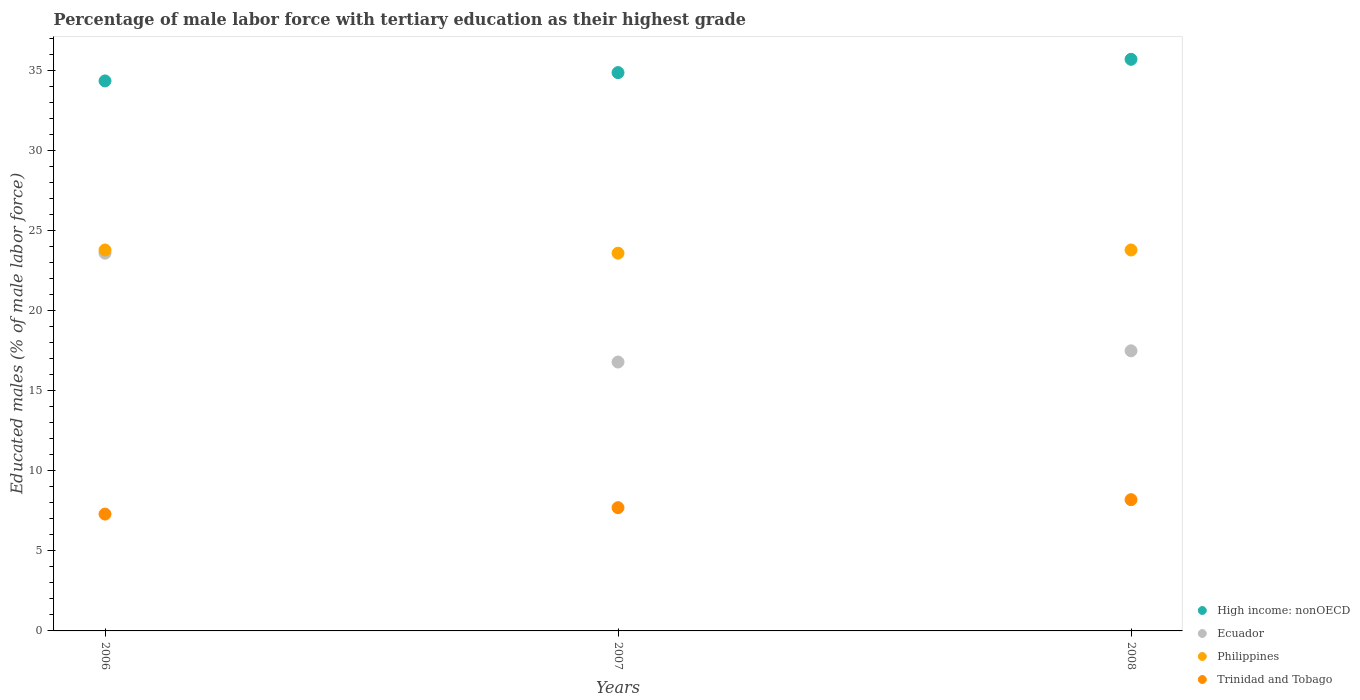Is the number of dotlines equal to the number of legend labels?
Keep it short and to the point. Yes. What is the percentage of male labor force with tertiary education in High income: nonOECD in 2006?
Provide a short and direct response. 34.36. Across all years, what is the maximum percentage of male labor force with tertiary education in Ecuador?
Ensure brevity in your answer.  23.6. Across all years, what is the minimum percentage of male labor force with tertiary education in Philippines?
Give a very brief answer. 23.6. In which year was the percentage of male labor force with tertiary education in Ecuador minimum?
Your response must be concise. 2007. What is the total percentage of male labor force with tertiary education in Philippines in the graph?
Your answer should be very brief. 71.2. What is the difference between the percentage of male labor force with tertiary education in Philippines in 2006 and that in 2007?
Your response must be concise. 0.2. What is the difference between the percentage of male labor force with tertiary education in Ecuador in 2006 and the percentage of male labor force with tertiary education in High income: nonOECD in 2008?
Keep it short and to the point. -12.11. What is the average percentage of male labor force with tertiary education in Trinidad and Tobago per year?
Your answer should be compact. 7.73. In the year 2006, what is the difference between the percentage of male labor force with tertiary education in Trinidad and Tobago and percentage of male labor force with tertiary education in Philippines?
Give a very brief answer. -16.5. In how many years, is the percentage of male labor force with tertiary education in Ecuador greater than 6 %?
Provide a short and direct response. 3. What is the ratio of the percentage of male labor force with tertiary education in Trinidad and Tobago in 2006 to that in 2008?
Your response must be concise. 0.89. Is the percentage of male labor force with tertiary education in Philippines in 2006 less than that in 2008?
Ensure brevity in your answer.  No. Is the difference between the percentage of male labor force with tertiary education in Trinidad and Tobago in 2006 and 2007 greater than the difference between the percentage of male labor force with tertiary education in Philippines in 2006 and 2007?
Your answer should be very brief. No. What is the difference between the highest and the second highest percentage of male labor force with tertiary education in High income: nonOECD?
Give a very brief answer. 0.83. What is the difference between the highest and the lowest percentage of male labor force with tertiary education in Ecuador?
Ensure brevity in your answer.  6.8. In how many years, is the percentage of male labor force with tertiary education in Ecuador greater than the average percentage of male labor force with tertiary education in Ecuador taken over all years?
Keep it short and to the point. 1. Is the sum of the percentage of male labor force with tertiary education in High income: nonOECD in 2006 and 2008 greater than the maximum percentage of male labor force with tertiary education in Philippines across all years?
Your answer should be very brief. Yes. Does the percentage of male labor force with tertiary education in Philippines monotonically increase over the years?
Ensure brevity in your answer.  No. Is the percentage of male labor force with tertiary education in Philippines strictly less than the percentage of male labor force with tertiary education in Ecuador over the years?
Your response must be concise. No. Are the values on the major ticks of Y-axis written in scientific E-notation?
Offer a very short reply. No. Does the graph contain any zero values?
Your answer should be compact. No. Does the graph contain grids?
Your answer should be compact. No. Where does the legend appear in the graph?
Your answer should be compact. Bottom right. How many legend labels are there?
Keep it short and to the point. 4. What is the title of the graph?
Your answer should be compact. Percentage of male labor force with tertiary education as their highest grade. What is the label or title of the X-axis?
Make the answer very short. Years. What is the label or title of the Y-axis?
Provide a short and direct response. Educated males (% of male labor force). What is the Educated males (% of male labor force) in High income: nonOECD in 2006?
Make the answer very short. 34.36. What is the Educated males (% of male labor force) in Ecuador in 2006?
Make the answer very short. 23.6. What is the Educated males (% of male labor force) in Philippines in 2006?
Your answer should be very brief. 23.8. What is the Educated males (% of male labor force) in Trinidad and Tobago in 2006?
Ensure brevity in your answer.  7.3. What is the Educated males (% of male labor force) in High income: nonOECD in 2007?
Your response must be concise. 34.88. What is the Educated males (% of male labor force) in Ecuador in 2007?
Offer a very short reply. 16.8. What is the Educated males (% of male labor force) in Philippines in 2007?
Keep it short and to the point. 23.6. What is the Educated males (% of male labor force) in Trinidad and Tobago in 2007?
Make the answer very short. 7.7. What is the Educated males (% of male labor force) in High income: nonOECD in 2008?
Offer a terse response. 35.71. What is the Educated males (% of male labor force) of Philippines in 2008?
Provide a succinct answer. 23.8. What is the Educated males (% of male labor force) of Trinidad and Tobago in 2008?
Your answer should be compact. 8.2. Across all years, what is the maximum Educated males (% of male labor force) in High income: nonOECD?
Your response must be concise. 35.71. Across all years, what is the maximum Educated males (% of male labor force) in Ecuador?
Offer a very short reply. 23.6. Across all years, what is the maximum Educated males (% of male labor force) of Philippines?
Offer a very short reply. 23.8. Across all years, what is the maximum Educated males (% of male labor force) of Trinidad and Tobago?
Provide a short and direct response. 8.2. Across all years, what is the minimum Educated males (% of male labor force) of High income: nonOECD?
Your response must be concise. 34.36. Across all years, what is the minimum Educated males (% of male labor force) in Ecuador?
Make the answer very short. 16.8. Across all years, what is the minimum Educated males (% of male labor force) of Philippines?
Provide a succinct answer. 23.6. Across all years, what is the minimum Educated males (% of male labor force) in Trinidad and Tobago?
Provide a short and direct response. 7.3. What is the total Educated males (% of male labor force) of High income: nonOECD in the graph?
Your answer should be compact. 104.95. What is the total Educated males (% of male labor force) of Ecuador in the graph?
Give a very brief answer. 57.9. What is the total Educated males (% of male labor force) of Philippines in the graph?
Keep it short and to the point. 71.2. What is the total Educated males (% of male labor force) in Trinidad and Tobago in the graph?
Give a very brief answer. 23.2. What is the difference between the Educated males (% of male labor force) of High income: nonOECD in 2006 and that in 2007?
Offer a terse response. -0.52. What is the difference between the Educated males (% of male labor force) in Ecuador in 2006 and that in 2007?
Your answer should be compact. 6.8. What is the difference between the Educated males (% of male labor force) of Philippines in 2006 and that in 2007?
Your answer should be compact. 0.2. What is the difference between the Educated males (% of male labor force) in High income: nonOECD in 2006 and that in 2008?
Your answer should be compact. -1.35. What is the difference between the Educated males (% of male labor force) in Ecuador in 2006 and that in 2008?
Provide a short and direct response. 6.1. What is the difference between the Educated males (% of male labor force) in Trinidad and Tobago in 2006 and that in 2008?
Your response must be concise. -0.9. What is the difference between the Educated males (% of male labor force) of High income: nonOECD in 2007 and that in 2008?
Your answer should be compact. -0.83. What is the difference between the Educated males (% of male labor force) of High income: nonOECD in 2006 and the Educated males (% of male labor force) of Ecuador in 2007?
Ensure brevity in your answer.  17.56. What is the difference between the Educated males (% of male labor force) in High income: nonOECD in 2006 and the Educated males (% of male labor force) in Philippines in 2007?
Provide a short and direct response. 10.76. What is the difference between the Educated males (% of male labor force) of High income: nonOECD in 2006 and the Educated males (% of male labor force) of Trinidad and Tobago in 2007?
Provide a succinct answer. 26.66. What is the difference between the Educated males (% of male labor force) of High income: nonOECD in 2006 and the Educated males (% of male labor force) of Ecuador in 2008?
Your answer should be very brief. 16.86. What is the difference between the Educated males (% of male labor force) of High income: nonOECD in 2006 and the Educated males (% of male labor force) of Philippines in 2008?
Offer a very short reply. 10.56. What is the difference between the Educated males (% of male labor force) of High income: nonOECD in 2006 and the Educated males (% of male labor force) of Trinidad and Tobago in 2008?
Your answer should be very brief. 26.16. What is the difference between the Educated males (% of male labor force) in Ecuador in 2006 and the Educated males (% of male labor force) in Philippines in 2008?
Offer a terse response. -0.2. What is the difference between the Educated males (% of male labor force) of Ecuador in 2006 and the Educated males (% of male labor force) of Trinidad and Tobago in 2008?
Make the answer very short. 15.4. What is the difference between the Educated males (% of male labor force) of High income: nonOECD in 2007 and the Educated males (% of male labor force) of Ecuador in 2008?
Keep it short and to the point. 17.38. What is the difference between the Educated males (% of male labor force) of High income: nonOECD in 2007 and the Educated males (% of male labor force) of Philippines in 2008?
Provide a succinct answer. 11.08. What is the difference between the Educated males (% of male labor force) in High income: nonOECD in 2007 and the Educated males (% of male labor force) in Trinidad and Tobago in 2008?
Ensure brevity in your answer.  26.68. What is the difference between the Educated males (% of male labor force) of Ecuador in 2007 and the Educated males (% of male labor force) of Trinidad and Tobago in 2008?
Provide a short and direct response. 8.6. What is the difference between the Educated males (% of male labor force) of Philippines in 2007 and the Educated males (% of male labor force) of Trinidad and Tobago in 2008?
Give a very brief answer. 15.4. What is the average Educated males (% of male labor force) in High income: nonOECD per year?
Your response must be concise. 34.98. What is the average Educated males (% of male labor force) in Ecuador per year?
Make the answer very short. 19.3. What is the average Educated males (% of male labor force) of Philippines per year?
Offer a very short reply. 23.73. What is the average Educated males (% of male labor force) of Trinidad and Tobago per year?
Provide a succinct answer. 7.73. In the year 2006, what is the difference between the Educated males (% of male labor force) of High income: nonOECD and Educated males (% of male labor force) of Ecuador?
Offer a terse response. 10.76. In the year 2006, what is the difference between the Educated males (% of male labor force) in High income: nonOECD and Educated males (% of male labor force) in Philippines?
Your response must be concise. 10.56. In the year 2006, what is the difference between the Educated males (% of male labor force) in High income: nonOECD and Educated males (% of male labor force) in Trinidad and Tobago?
Your answer should be very brief. 27.06. In the year 2006, what is the difference between the Educated males (% of male labor force) of Philippines and Educated males (% of male labor force) of Trinidad and Tobago?
Your response must be concise. 16.5. In the year 2007, what is the difference between the Educated males (% of male labor force) of High income: nonOECD and Educated males (% of male labor force) of Ecuador?
Your response must be concise. 18.08. In the year 2007, what is the difference between the Educated males (% of male labor force) of High income: nonOECD and Educated males (% of male labor force) of Philippines?
Offer a terse response. 11.28. In the year 2007, what is the difference between the Educated males (% of male labor force) in High income: nonOECD and Educated males (% of male labor force) in Trinidad and Tobago?
Your answer should be very brief. 27.18. In the year 2007, what is the difference between the Educated males (% of male labor force) of Ecuador and Educated males (% of male labor force) of Trinidad and Tobago?
Keep it short and to the point. 9.1. In the year 2007, what is the difference between the Educated males (% of male labor force) of Philippines and Educated males (% of male labor force) of Trinidad and Tobago?
Provide a succinct answer. 15.9. In the year 2008, what is the difference between the Educated males (% of male labor force) in High income: nonOECD and Educated males (% of male labor force) in Ecuador?
Your answer should be very brief. 18.21. In the year 2008, what is the difference between the Educated males (% of male labor force) of High income: nonOECD and Educated males (% of male labor force) of Philippines?
Offer a very short reply. 11.91. In the year 2008, what is the difference between the Educated males (% of male labor force) of High income: nonOECD and Educated males (% of male labor force) of Trinidad and Tobago?
Offer a very short reply. 27.51. In the year 2008, what is the difference between the Educated males (% of male labor force) in Ecuador and Educated males (% of male labor force) in Trinidad and Tobago?
Your answer should be very brief. 9.3. In the year 2008, what is the difference between the Educated males (% of male labor force) in Philippines and Educated males (% of male labor force) in Trinidad and Tobago?
Provide a succinct answer. 15.6. What is the ratio of the Educated males (% of male labor force) of High income: nonOECD in 2006 to that in 2007?
Keep it short and to the point. 0.99. What is the ratio of the Educated males (% of male labor force) in Ecuador in 2006 to that in 2007?
Your answer should be very brief. 1.4. What is the ratio of the Educated males (% of male labor force) of Philippines in 2006 to that in 2007?
Provide a short and direct response. 1.01. What is the ratio of the Educated males (% of male labor force) in Trinidad and Tobago in 2006 to that in 2007?
Provide a short and direct response. 0.95. What is the ratio of the Educated males (% of male labor force) in High income: nonOECD in 2006 to that in 2008?
Provide a succinct answer. 0.96. What is the ratio of the Educated males (% of male labor force) of Ecuador in 2006 to that in 2008?
Give a very brief answer. 1.35. What is the ratio of the Educated males (% of male labor force) of Trinidad and Tobago in 2006 to that in 2008?
Ensure brevity in your answer.  0.89. What is the ratio of the Educated males (% of male labor force) of High income: nonOECD in 2007 to that in 2008?
Provide a succinct answer. 0.98. What is the ratio of the Educated males (% of male labor force) in Ecuador in 2007 to that in 2008?
Provide a succinct answer. 0.96. What is the ratio of the Educated males (% of male labor force) in Trinidad and Tobago in 2007 to that in 2008?
Offer a very short reply. 0.94. What is the difference between the highest and the second highest Educated males (% of male labor force) of High income: nonOECD?
Offer a very short reply. 0.83. What is the difference between the highest and the lowest Educated males (% of male labor force) of High income: nonOECD?
Your answer should be compact. 1.35. What is the difference between the highest and the lowest Educated males (% of male labor force) in Ecuador?
Keep it short and to the point. 6.8. What is the difference between the highest and the lowest Educated males (% of male labor force) in Trinidad and Tobago?
Provide a short and direct response. 0.9. 